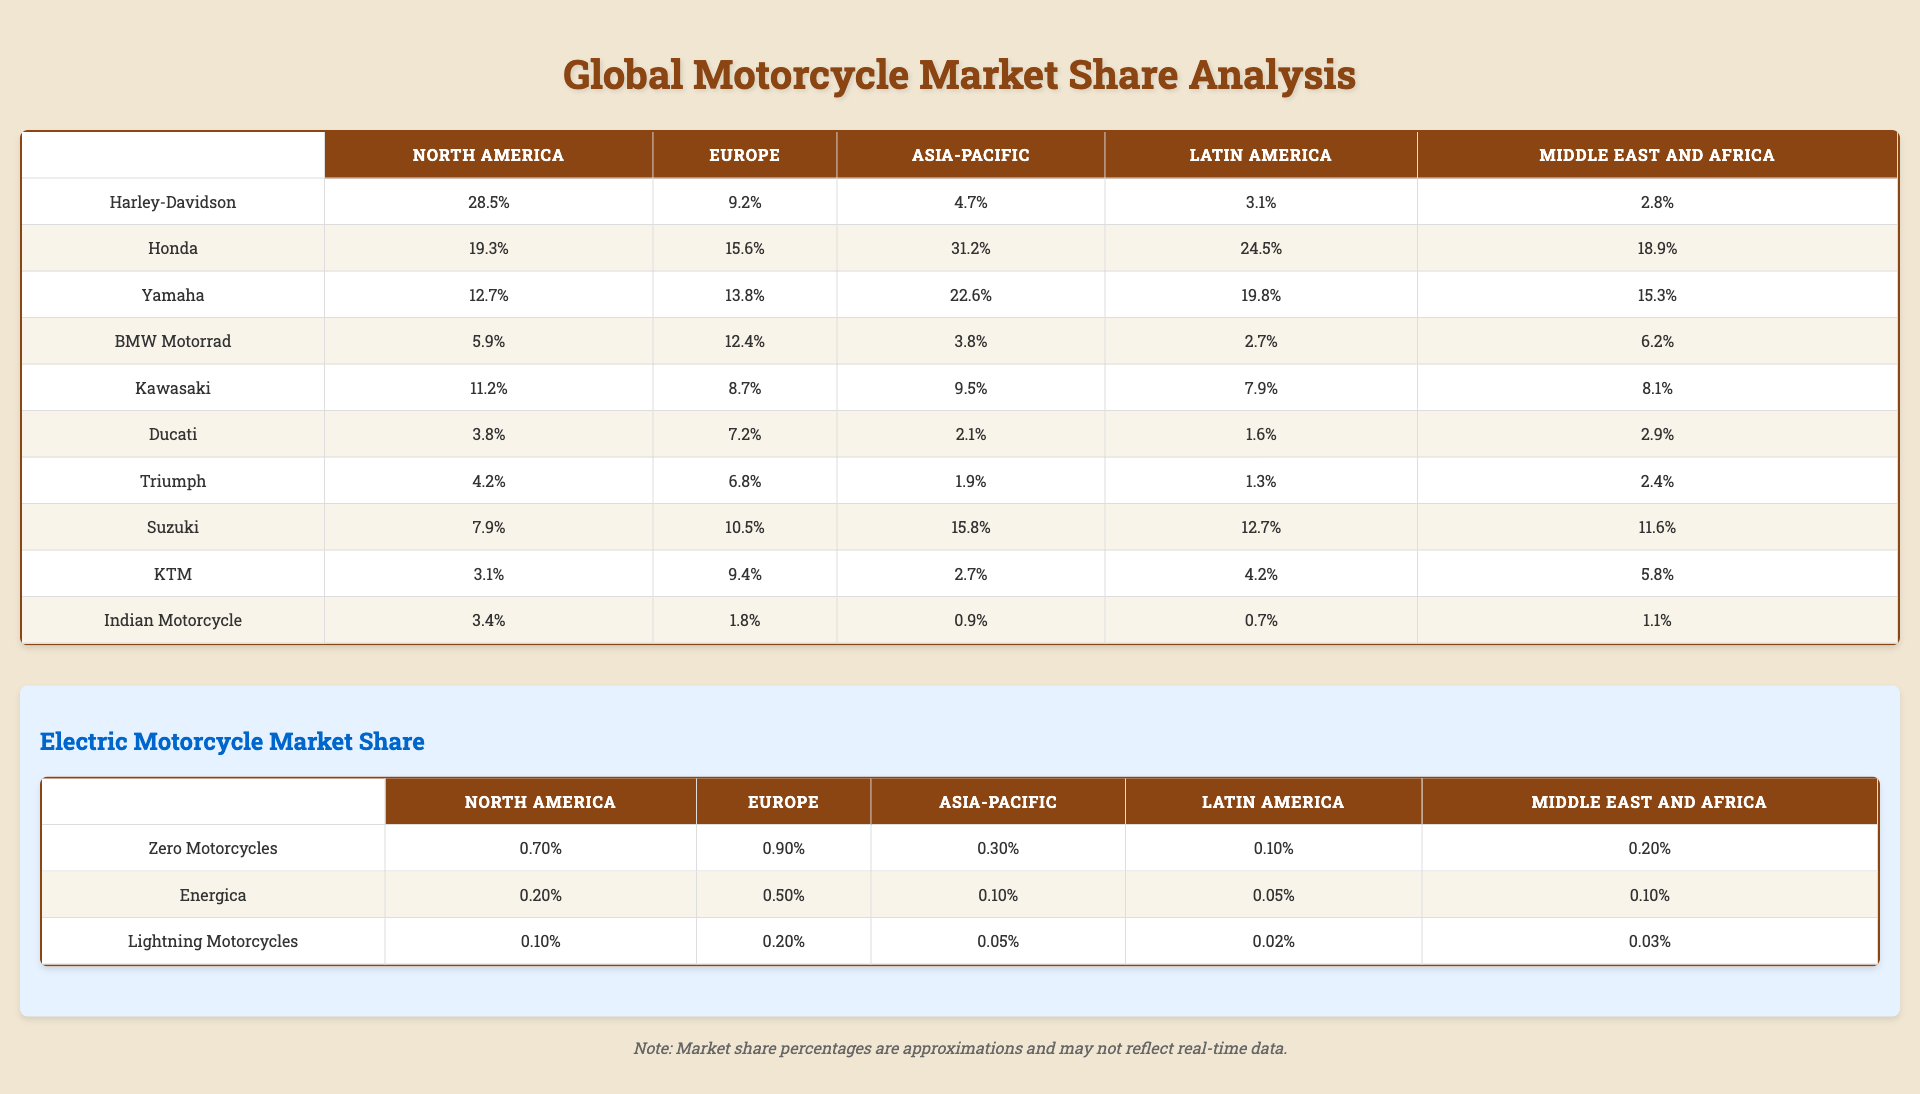What is the market share of Harley-Davidson in North America? According to the table, Harley-Davidson has a market share of 28.5% in North America.
Answer: 28.5% Which brand has the highest market share in the Asia-Pacific region? By looking at the Asia-Pacific column, Honda shows the highest market share at 31.2%.
Answer: Honda What is the sum of the market shares of all brands in Latin America? The market shares listed for Latin America are: Harley-Davidson (3.1%), Honda (24.5%), Yamaha (19.8%), BMW Motorrad (2.7%), Kawasaki (7.9%), Ducati (1.6%), Triumph (1.3%), Suzuki (12.7%), KTM (4.2%), and Indian Motorcycle (0.7%). Summing these gives 3.1 + 24.5 + 19.8 + 2.7 + 7.9 + 1.6 + 1.3 + 12.7 + 4.2 + 0.7 = 78.4%.
Answer: 78.4% Which two brands have similar market shares in Europe, and what are their values? Looking at the European market shares, Yamaha (13.8%) and BMW Motorrad (12.4%) are relatively close.
Answer: Yamaha 13.8%, BMW Motorrad 12.4% Is the market share of Indian Motorcycle higher in North America than in Europe? In North America, Indian Motorcycle has a market share of 3.4%, whereas in Europe it is only 1.8%. Since 3.4% is greater than 1.8%, the statement is true.
Answer: Yes What is the average market share of Honda across all regions? To calculate, we sum Honda's market shares across all regions: 19.3 (North America) + 15.6 (Europe) + 31.2 (Asia-Pacific) + 24.5 (Latin America) + 18.9 (Middle East and Africa) = 109.5%. Dividing by 5 regions gives an average of 109.5/5 = 21.9%.
Answer: 21.9% Which brand has the lowest market share in the Middle East and Africa? In the Middle East and Africa column, Indian Motorcycle has the lowest market share at 1.1%.
Answer: Indian Motorcycle If you compare Yamaha's market share in North America and Europe, how much higher is it in North America? Yamaha's market share in North America is 12.7% and in Europe, it is 13.8%. The difference is 12.7 - 13.8 = -1.1%, indicating it is lower in North America.
Answer: -1.1% What is the total electric market share of Zero Motorcycles across all regions? The electric market shares for Zero Motorcycles are: North America (0.7%), Europe (0.9%), Asia-Pacific (0.3%), Latin America (0.1%), and Middle East and Africa (0.2%). Adding these gives 0.7 + 0.9 + 0.3 + 0.1 + 0.2 = 2.2%.
Answer: 2.2% Is it true that Ducati has a higher market share in Europe than in North America? In Europe, Ducati has 7.2%, while in North America it has only 3.8%. Since 7.2% is greater than 3.8%, the statement is true.
Answer: Yes What is the percentage difference between Honda's market share in Asia-Pacific and that of Ducati in the same region? Honda's market share in Asia-Pacific is 31.2% and Ducati's is 2.1%. The difference is 31.2 - 2.1 = 29.1%.
Answer: 29.1% 